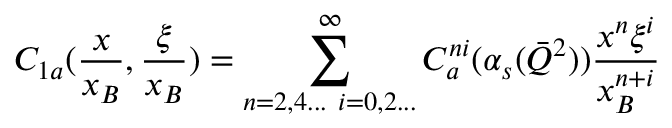Convert formula to latex. <formula><loc_0><loc_0><loc_500><loc_500>C _ { 1 a } ( { \frac { x } { x _ { B } } } , { \frac { \xi } { x _ { B } } } ) = \sum _ { n = 2 , 4 \dots i = 0 , 2 \dots } ^ { \infty } C _ { a } ^ { n i } ( \alpha _ { s } ( \bar { Q } ^ { 2 } ) ) { \frac { x ^ { n } \xi ^ { i } } { x _ { B } ^ { n + i } } }</formula> 